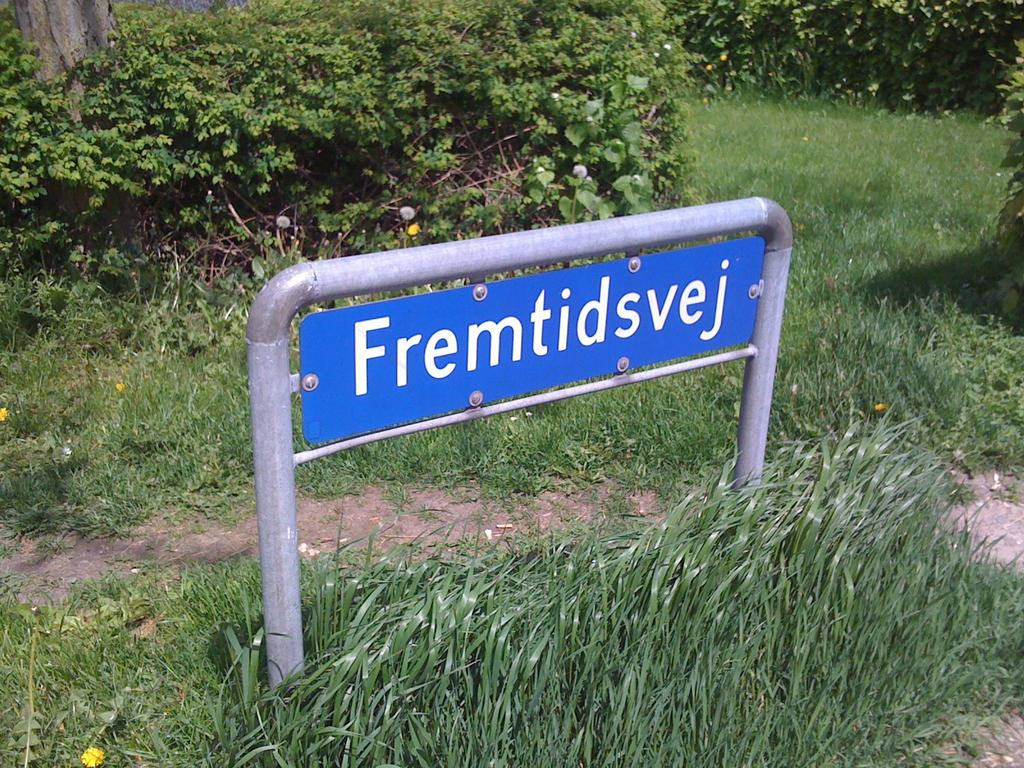What is the main object in the center of the image? There is a name board in the center of the image. What type of ground is visible at the bottom of the image? There is grass at the bottom of the image. What can be seen in the background of the image? There are plants in the background of the image. What part of a tree can be seen in the image? There is a tree trunk visible in the image. What story do the brothers tell each other while sitting under the tree in the image? There are no brothers or any indication of a story being told in the image. The image only features a name board, grass, plants, and a tree trunk. 